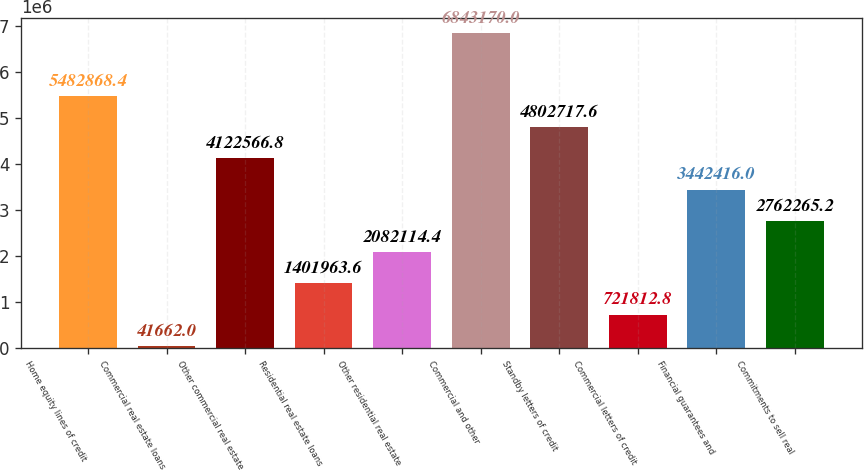Convert chart. <chart><loc_0><loc_0><loc_500><loc_500><bar_chart><fcel>Home equity lines of credit<fcel>Commercial real estate loans<fcel>Other commercial real estate<fcel>Residential real estate loans<fcel>Other residential real estate<fcel>Commercial and other<fcel>Standby letters of credit<fcel>Commercial letters of credit<fcel>Financial guarantees and<fcel>Commitments to sell real<nl><fcel>5.48287e+06<fcel>41662<fcel>4.12257e+06<fcel>1.40196e+06<fcel>2.08211e+06<fcel>6.84317e+06<fcel>4.80272e+06<fcel>721813<fcel>3.44242e+06<fcel>2.76227e+06<nl></chart> 